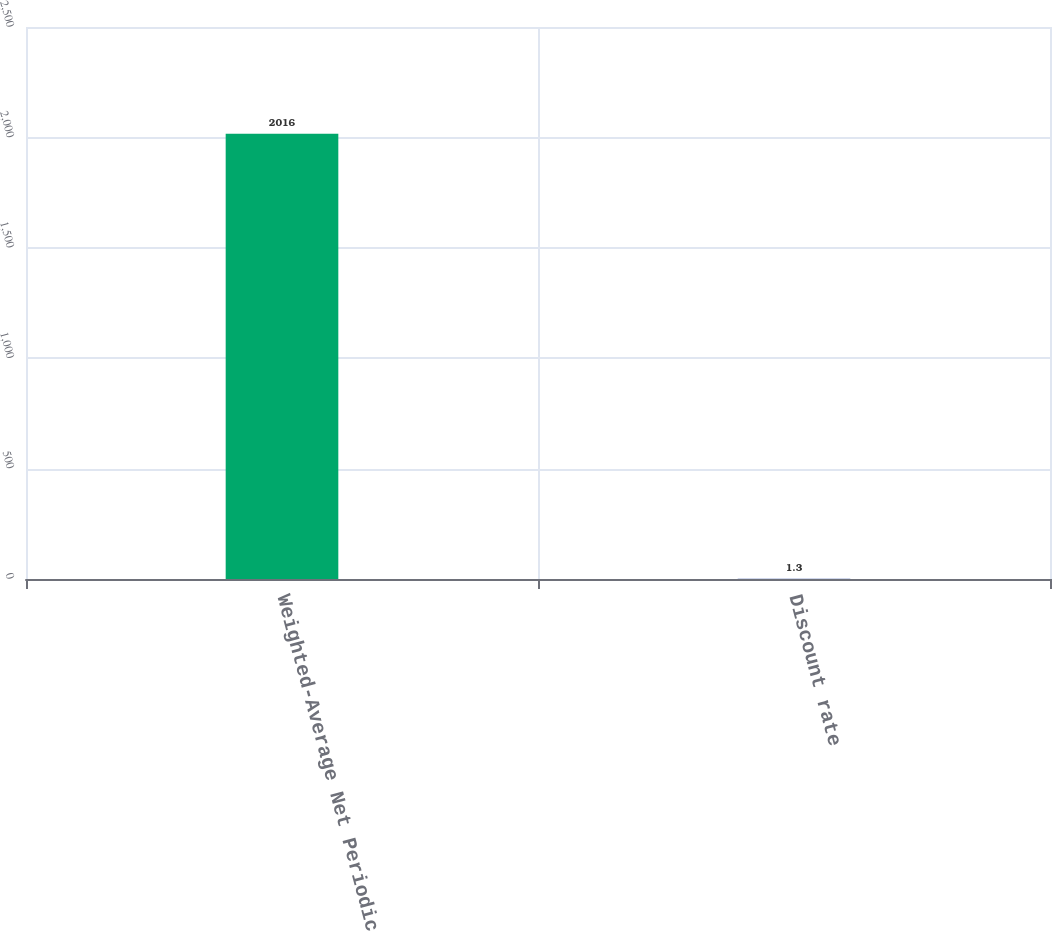Convert chart to OTSL. <chart><loc_0><loc_0><loc_500><loc_500><bar_chart><fcel>Weighted-Average Net Periodic<fcel>Discount rate<nl><fcel>2016<fcel>1.3<nl></chart> 